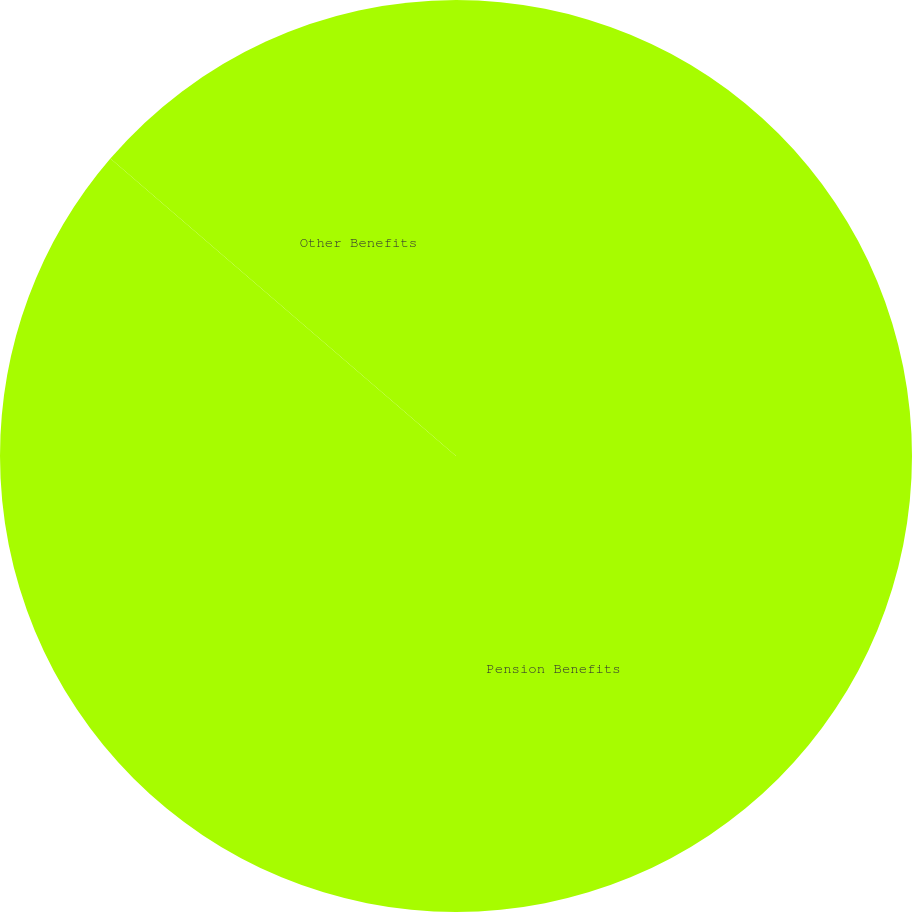Convert chart. <chart><loc_0><loc_0><loc_500><loc_500><pie_chart><fcel>Pension Benefits<fcel>Other Benefits<nl><fcel>86.31%<fcel>13.69%<nl></chart> 